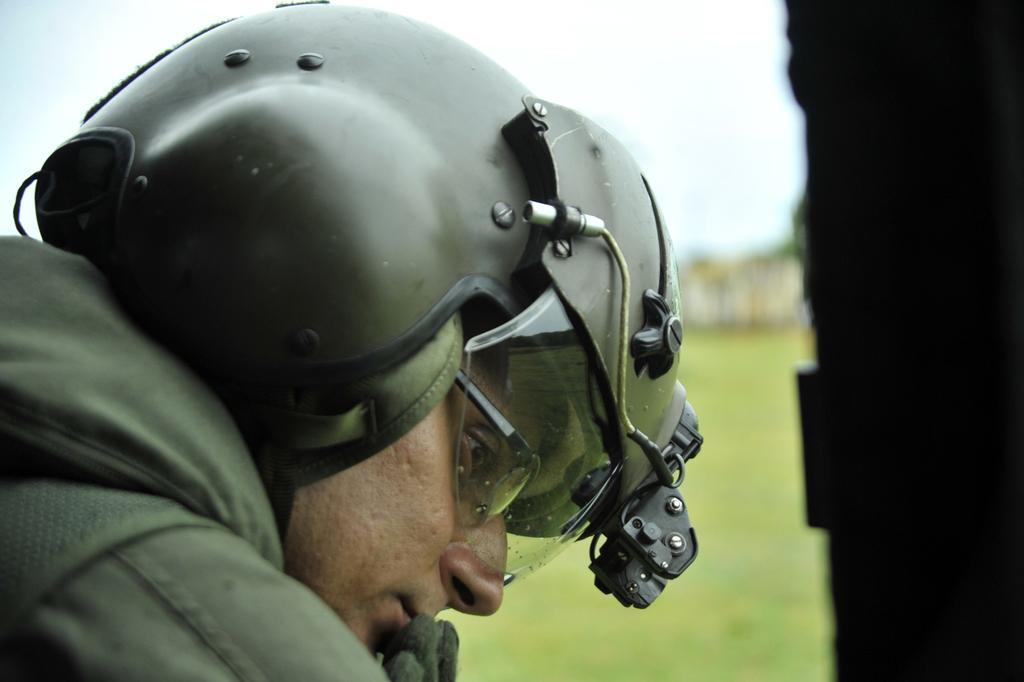Could you give a brief overview of what you see in this image? In this image there is a man wearing a helmet, in the background it is blurred. 